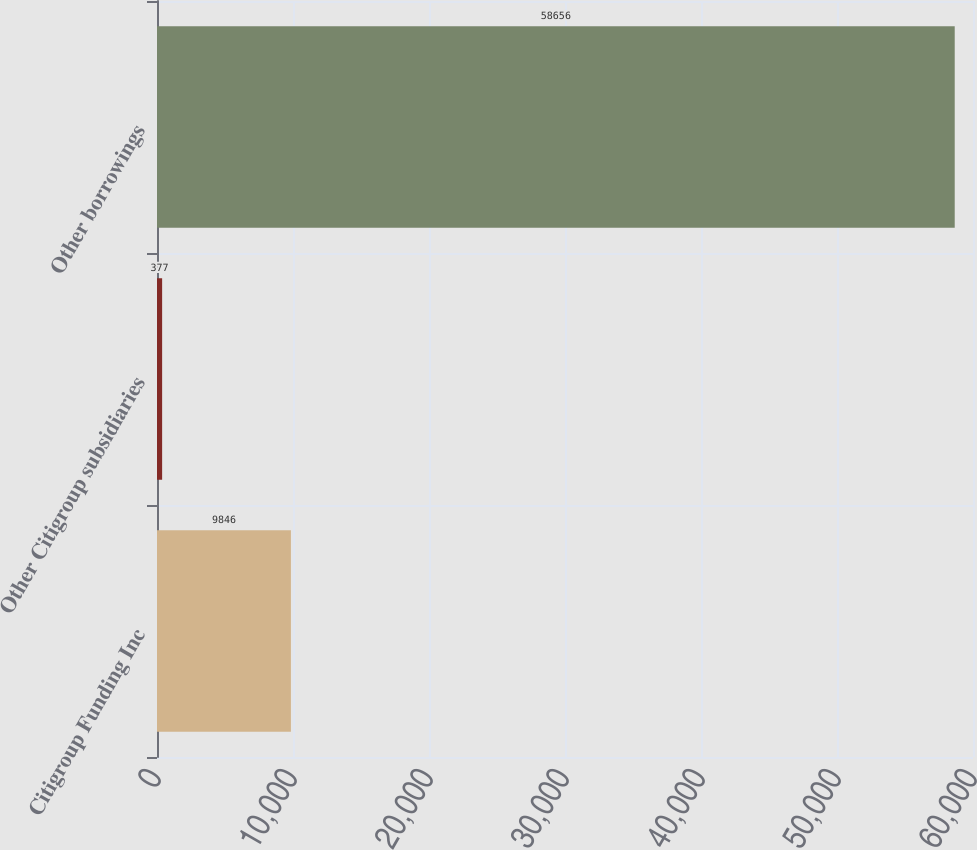<chart> <loc_0><loc_0><loc_500><loc_500><bar_chart><fcel>Citigroup Funding Inc<fcel>Other Citigroup subsidiaries<fcel>Other borrowings<nl><fcel>9846<fcel>377<fcel>58656<nl></chart> 